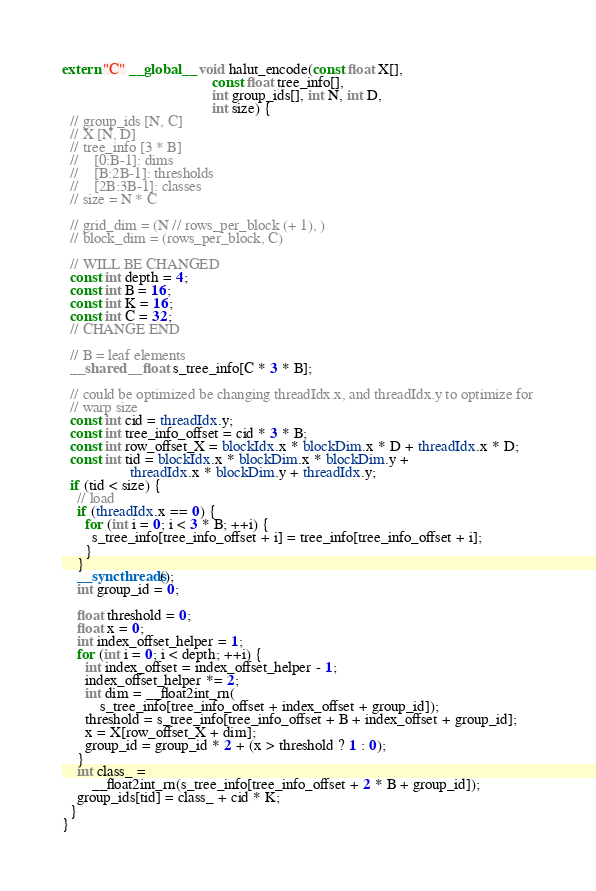<code> <loc_0><loc_0><loc_500><loc_500><_Cuda_>extern "C" __global__ void halut_encode(const float X[],
                                        const float tree_info[],
                                        int group_ids[], int N, int D,
                                        int size) {
  // group_ids [N, C]
  // X [N, D]
  // tree_info [3 * B]
  //    [0:B-1]: dims
  //    [B:2B-1]: thresholds
  //    [2B:3B-1]: classes
  // size = N * C

  // grid_dim = (N // rows_per_block (+ 1), )
  // block_dim = (rows_per_block, C)

  // WILL BE CHANGED
  const int depth = 4;
  const int B = 16;
  const int K = 16;
  const int C = 32;
  // CHANGE END

  // B = leaf elements
  __shared__ float s_tree_info[C * 3 * B];

  // could be optimized be changing threadIdx.x, and threadIdx.y to optimize for
  // warp size
  const int cid = threadIdx.y;
  const int tree_info_offset = cid * 3 * B;
  const int row_offset_X = blockIdx.x * blockDim.x * D + threadIdx.x * D;
  const int tid = blockIdx.x * blockDim.x * blockDim.y +
                  threadIdx.x * blockDim.y + threadIdx.y;
  if (tid < size) {
    // load
    if (threadIdx.x == 0) {
      for (int i = 0; i < 3 * B; ++i) {
        s_tree_info[tree_info_offset + i] = tree_info[tree_info_offset + i];
      }
    }
    __syncthreads();
    int group_id = 0;

    float threshold = 0;
    float x = 0;
    int index_offset_helper = 1;
    for (int i = 0; i < depth; ++i) {
      int index_offset = index_offset_helper - 1;
      index_offset_helper *= 2;
      int dim = __float2int_rn(
          s_tree_info[tree_info_offset + index_offset + group_id]);
      threshold = s_tree_info[tree_info_offset + B + index_offset + group_id];
      x = X[row_offset_X + dim];
      group_id = group_id * 2 + (x > threshold ? 1 : 0);
    }
    int class_ =
        __float2int_rn(s_tree_info[tree_info_offset + 2 * B + group_id]);
    group_ids[tid] = class_ + cid * K;
  }
}</code> 